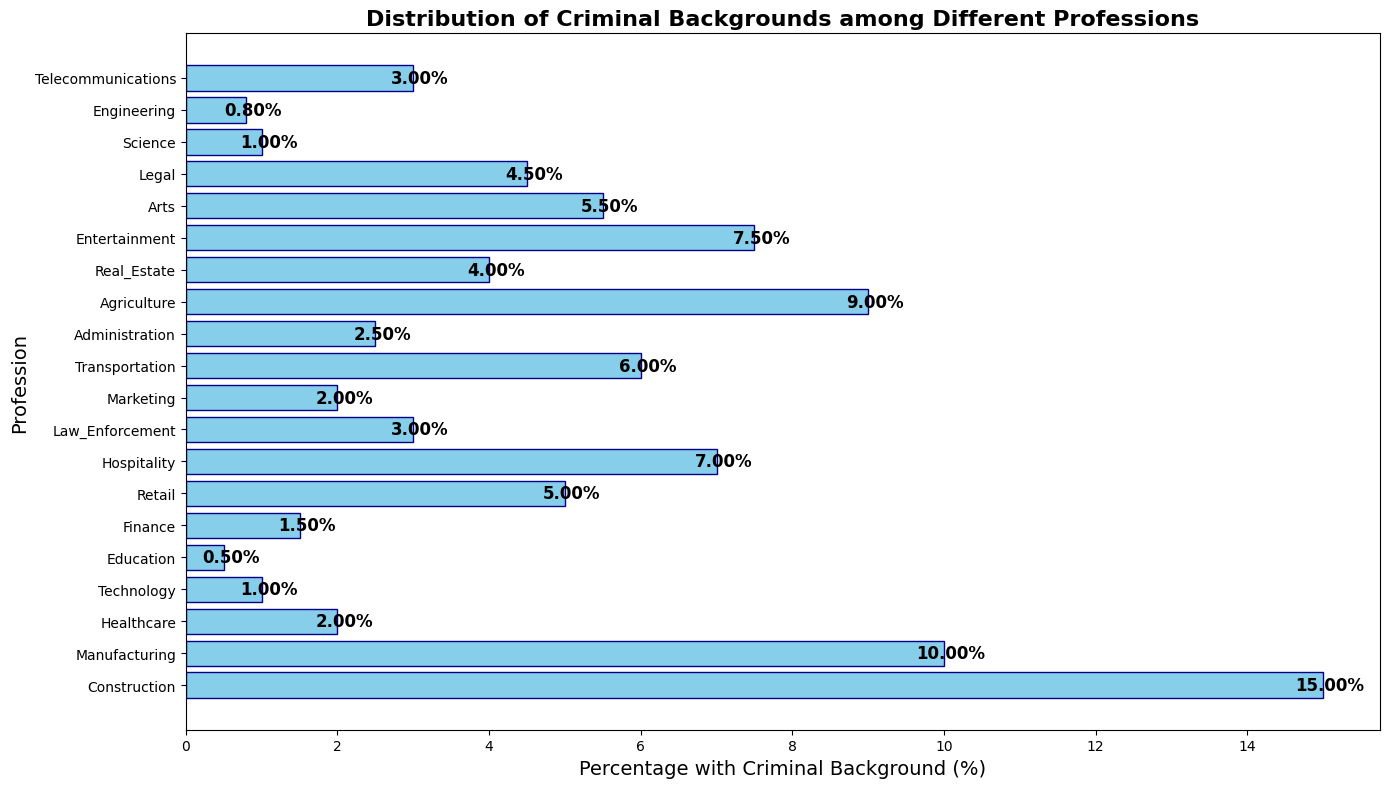Which profession has the highest percentage of workers with a criminal background? The bar for Construction is the tallest, indicating it has the highest percentage.
Answer: Construction How much higher is the percentage of workers with a criminal background in Construction compared to Technology? The bar for Construction is around 15%, and for Technology, it's about 1%. The difference is 15% - 1% = 14%.
Answer: 14% What is the approximate average percentage of workers with a criminal background across all professions shown? Sum the percentages of all professions and divide by the number of professions (20). This yields (15 + 10 + 2 + 1 + 0.5 + 1.5 + 5 + 7 + 3 + 2 + 6 + 2.5 + 9 + 4 + 7.5 + 5.5 + 4.5 + 1 + 0.8 + 3) / 20 = 4.19%.
Answer: 4.19% Which profession has a lower percentage of workers with a criminal background: Healthcare or Finance? The bar for Healthcare is lower than the bar for Finance, with Healthcare at about 2% and Finance at approximately 1.5%.
Answer: Finance Is the percentage of workers with a criminal background in Hospitality above or below 5%? The bar for Hospitality is right above the 7% mark, which is above 5%.
Answer: Above Which two professions have the smallest percentage of workers with a criminal background, and what are those percentages? The bars for Engineering and Technology are the smallest, both below 2%. Engineering is at 0.8% and Technology is at 1%.
Answer: Engineering and Technology, 0.8% and 1% How much higher is the percentage of workers with a criminal background in Manufacturing compared to Real Estate and Agriculture? The bar for Manufacturing is at 10%, for Real Estate it's around 4%, and for Agriculture, it's approximately 9%. The combined average of Real Estate and Agriculture is (4% + 9%) / 2 = 6.5%. The difference is 10% - 6.5% = 3.5%.
Answer: 3.5% What is the difference in percentage of workers with a criminal background between Education and Arts? The bar for Education is at 0.5%, and for Arts, it's around 5.5%. The difference is 5.5% - 0.5% = 5%.
Answer: 5% Which profession is exactly at 2.5% in terms of workers with a criminal background? The bar for Administration is exactly at the 2.5% mark.
Answer: Administration Are there more professions with a percentage of workers with a criminal background above or below 5%? Counting the bars, there are 7 professions above 5% and 13 below 5%. More professions are below 5%.
Answer: Below 